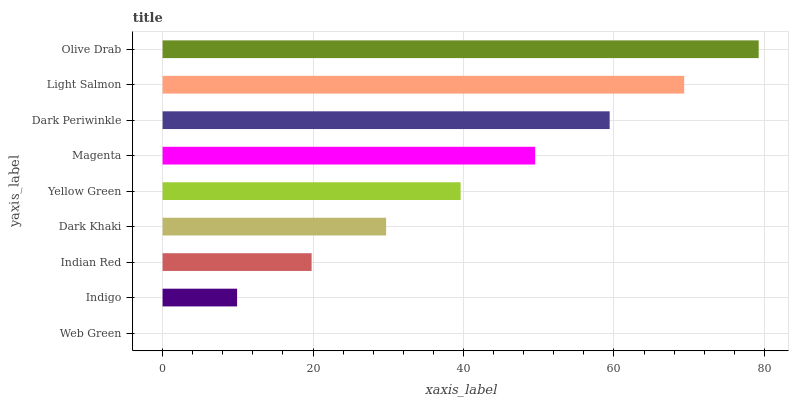Is Web Green the minimum?
Answer yes or no. Yes. Is Olive Drab the maximum?
Answer yes or no. Yes. Is Indigo the minimum?
Answer yes or no. No. Is Indigo the maximum?
Answer yes or no. No. Is Indigo greater than Web Green?
Answer yes or no. Yes. Is Web Green less than Indigo?
Answer yes or no. Yes. Is Web Green greater than Indigo?
Answer yes or no. No. Is Indigo less than Web Green?
Answer yes or no. No. Is Yellow Green the high median?
Answer yes or no. Yes. Is Yellow Green the low median?
Answer yes or no. Yes. Is Indigo the high median?
Answer yes or no. No. Is Magenta the low median?
Answer yes or no. No. 